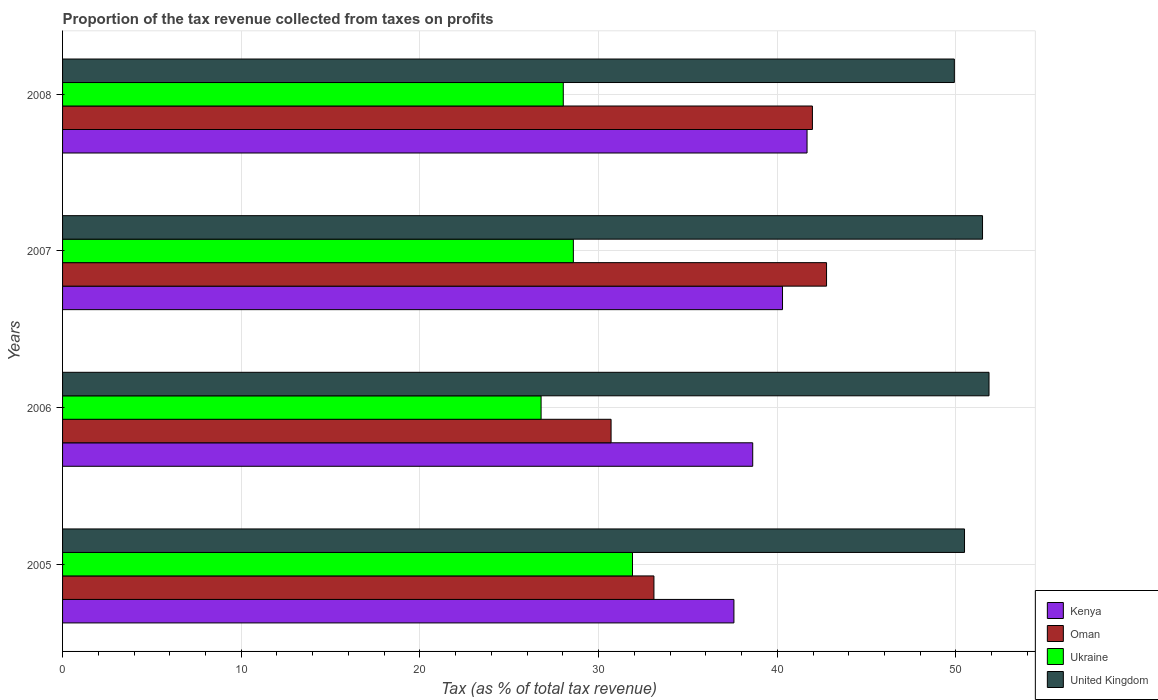How many groups of bars are there?
Your answer should be very brief. 4. Are the number of bars per tick equal to the number of legend labels?
Ensure brevity in your answer.  Yes. Are the number of bars on each tick of the Y-axis equal?
Offer a terse response. Yes. How many bars are there on the 1st tick from the bottom?
Your answer should be very brief. 4. What is the label of the 2nd group of bars from the top?
Offer a terse response. 2007. What is the proportion of the tax revenue collected in United Kingdom in 2005?
Offer a very short reply. 50.48. Across all years, what is the maximum proportion of the tax revenue collected in Ukraine?
Your answer should be very brief. 31.9. Across all years, what is the minimum proportion of the tax revenue collected in Ukraine?
Your response must be concise. 26.78. In which year was the proportion of the tax revenue collected in Ukraine maximum?
Keep it short and to the point. 2005. What is the total proportion of the tax revenue collected in Kenya in the graph?
Give a very brief answer. 158.15. What is the difference between the proportion of the tax revenue collected in Oman in 2005 and that in 2007?
Your response must be concise. -9.66. What is the difference between the proportion of the tax revenue collected in United Kingdom in 2005 and the proportion of the tax revenue collected in Oman in 2007?
Offer a terse response. 7.72. What is the average proportion of the tax revenue collected in Kenya per year?
Keep it short and to the point. 39.54. In the year 2005, what is the difference between the proportion of the tax revenue collected in Kenya and proportion of the tax revenue collected in Ukraine?
Offer a very short reply. 5.68. What is the ratio of the proportion of the tax revenue collected in Oman in 2006 to that in 2007?
Give a very brief answer. 0.72. Is the proportion of the tax revenue collected in Oman in 2005 less than that in 2007?
Offer a very short reply. Yes. What is the difference between the highest and the second highest proportion of the tax revenue collected in Ukraine?
Ensure brevity in your answer.  3.31. What is the difference between the highest and the lowest proportion of the tax revenue collected in Ukraine?
Give a very brief answer. 5.12. In how many years, is the proportion of the tax revenue collected in Oman greater than the average proportion of the tax revenue collected in Oman taken over all years?
Provide a succinct answer. 2. Is it the case that in every year, the sum of the proportion of the tax revenue collected in Ukraine and proportion of the tax revenue collected in Kenya is greater than the sum of proportion of the tax revenue collected in Oman and proportion of the tax revenue collected in United Kingdom?
Provide a short and direct response. Yes. What does the 2nd bar from the top in 2007 represents?
Provide a succinct answer. Ukraine. How many years are there in the graph?
Make the answer very short. 4. What is the difference between two consecutive major ticks on the X-axis?
Your answer should be very brief. 10. Does the graph contain any zero values?
Provide a succinct answer. No. Where does the legend appear in the graph?
Offer a terse response. Bottom right. How are the legend labels stacked?
Keep it short and to the point. Vertical. What is the title of the graph?
Keep it short and to the point. Proportion of the tax revenue collected from taxes on profits. What is the label or title of the X-axis?
Offer a terse response. Tax (as % of total tax revenue). What is the Tax (as % of total tax revenue) in Kenya in 2005?
Provide a short and direct response. 37.57. What is the Tax (as % of total tax revenue) of Oman in 2005?
Offer a very short reply. 33.1. What is the Tax (as % of total tax revenue) of Ukraine in 2005?
Make the answer very short. 31.9. What is the Tax (as % of total tax revenue) of United Kingdom in 2005?
Your answer should be very brief. 50.48. What is the Tax (as % of total tax revenue) of Kenya in 2006?
Give a very brief answer. 38.62. What is the Tax (as % of total tax revenue) of Oman in 2006?
Make the answer very short. 30.7. What is the Tax (as % of total tax revenue) of Ukraine in 2006?
Ensure brevity in your answer.  26.78. What is the Tax (as % of total tax revenue) in United Kingdom in 2006?
Make the answer very short. 51.85. What is the Tax (as % of total tax revenue) of Kenya in 2007?
Your answer should be compact. 40.29. What is the Tax (as % of total tax revenue) of Oman in 2007?
Offer a very short reply. 42.76. What is the Tax (as % of total tax revenue) in Ukraine in 2007?
Keep it short and to the point. 28.59. What is the Tax (as % of total tax revenue) of United Kingdom in 2007?
Give a very brief answer. 51.49. What is the Tax (as % of total tax revenue) in Kenya in 2008?
Your answer should be compact. 41.67. What is the Tax (as % of total tax revenue) in Oman in 2008?
Ensure brevity in your answer.  41.97. What is the Tax (as % of total tax revenue) in Ukraine in 2008?
Offer a terse response. 28.02. What is the Tax (as % of total tax revenue) in United Kingdom in 2008?
Give a very brief answer. 49.91. Across all years, what is the maximum Tax (as % of total tax revenue) of Kenya?
Provide a succinct answer. 41.67. Across all years, what is the maximum Tax (as % of total tax revenue) of Oman?
Offer a terse response. 42.76. Across all years, what is the maximum Tax (as % of total tax revenue) of Ukraine?
Make the answer very short. 31.9. Across all years, what is the maximum Tax (as % of total tax revenue) in United Kingdom?
Offer a terse response. 51.85. Across all years, what is the minimum Tax (as % of total tax revenue) of Kenya?
Your answer should be very brief. 37.57. Across all years, what is the minimum Tax (as % of total tax revenue) in Oman?
Provide a short and direct response. 30.7. Across all years, what is the minimum Tax (as % of total tax revenue) in Ukraine?
Make the answer very short. 26.78. Across all years, what is the minimum Tax (as % of total tax revenue) of United Kingdom?
Provide a short and direct response. 49.91. What is the total Tax (as % of total tax revenue) of Kenya in the graph?
Give a very brief answer. 158.15. What is the total Tax (as % of total tax revenue) of Oman in the graph?
Offer a very short reply. 148.51. What is the total Tax (as % of total tax revenue) of Ukraine in the graph?
Ensure brevity in your answer.  115.29. What is the total Tax (as % of total tax revenue) of United Kingdom in the graph?
Give a very brief answer. 203.72. What is the difference between the Tax (as % of total tax revenue) of Kenya in 2005 and that in 2006?
Provide a short and direct response. -1.05. What is the difference between the Tax (as % of total tax revenue) of Oman in 2005 and that in 2006?
Keep it short and to the point. 2.4. What is the difference between the Tax (as % of total tax revenue) of Ukraine in 2005 and that in 2006?
Ensure brevity in your answer.  5.12. What is the difference between the Tax (as % of total tax revenue) of United Kingdom in 2005 and that in 2006?
Your response must be concise. -1.37. What is the difference between the Tax (as % of total tax revenue) in Kenya in 2005 and that in 2007?
Ensure brevity in your answer.  -2.72. What is the difference between the Tax (as % of total tax revenue) in Oman in 2005 and that in 2007?
Your answer should be compact. -9.66. What is the difference between the Tax (as % of total tax revenue) of Ukraine in 2005 and that in 2007?
Make the answer very short. 3.31. What is the difference between the Tax (as % of total tax revenue) of United Kingdom in 2005 and that in 2007?
Your answer should be very brief. -1.01. What is the difference between the Tax (as % of total tax revenue) in Kenya in 2005 and that in 2008?
Your answer should be very brief. -4.09. What is the difference between the Tax (as % of total tax revenue) in Oman in 2005 and that in 2008?
Ensure brevity in your answer.  -8.87. What is the difference between the Tax (as % of total tax revenue) in Ukraine in 2005 and that in 2008?
Offer a terse response. 3.87. What is the difference between the Tax (as % of total tax revenue) of United Kingdom in 2005 and that in 2008?
Your answer should be compact. 0.57. What is the difference between the Tax (as % of total tax revenue) of Kenya in 2006 and that in 2007?
Provide a short and direct response. -1.67. What is the difference between the Tax (as % of total tax revenue) in Oman in 2006 and that in 2007?
Provide a short and direct response. -12.06. What is the difference between the Tax (as % of total tax revenue) of Ukraine in 2006 and that in 2007?
Provide a short and direct response. -1.81. What is the difference between the Tax (as % of total tax revenue) in United Kingdom in 2006 and that in 2007?
Your answer should be very brief. 0.36. What is the difference between the Tax (as % of total tax revenue) of Kenya in 2006 and that in 2008?
Provide a short and direct response. -3.04. What is the difference between the Tax (as % of total tax revenue) in Oman in 2006 and that in 2008?
Provide a succinct answer. -11.27. What is the difference between the Tax (as % of total tax revenue) in Ukraine in 2006 and that in 2008?
Your response must be concise. -1.24. What is the difference between the Tax (as % of total tax revenue) in United Kingdom in 2006 and that in 2008?
Make the answer very short. 1.94. What is the difference between the Tax (as % of total tax revenue) in Kenya in 2007 and that in 2008?
Ensure brevity in your answer.  -1.37. What is the difference between the Tax (as % of total tax revenue) of Oman in 2007 and that in 2008?
Provide a short and direct response. 0.79. What is the difference between the Tax (as % of total tax revenue) in Ukraine in 2007 and that in 2008?
Keep it short and to the point. 0.56. What is the difference between the Tax (as % of total tax revenue) of United Kingdom in 2007 and that in 2008?
Your response must be concise. 1.58. What is the difference between the Tax (as % of total tax revenue) of Kenya in 2005 and the Tax (as % of total tax revenue) of Oman in 2006?
Make the answer very short. 6.88. What is the difference between the Tax (as % of total tax revenue) in Kenya in 2005 and the Tax (as % of total tax revenue) in Ukraine in 2006?
Make the answer very short. 10.79. What is the difference between the Tax (as % of total tax revenue) in Kenya in 2005 and the Tax (as % of total tax revenue) in United Kingdom in 2006?
Give a very brief answer. -14.28. What is the difference between the Tax (as % of total tax revenue) in Oman in 2005 and the Tax (as % of total tax revenue) in Ukraine in 2006?
Give a very brief answer. 6.32. What is the difference between the Tax (as % of total tax revenue) of Oman in 2005 and the Tax (as % of total tax revenue) of United Kingdom in 2006?
Your response must be concise. -18.75. What is the difference between the Tax (as % of total tax revenue) of Ukraine in 2005 and the Tax (as % of total tax revenue) of United Kingdom in 2006?
Provide a succinct answer. -19.95. What is the difference between the Tax (as % of total tax revenue) of Kenya in 2005 and the Tax (as % of total tax revenue) of Oman in 2007?
Your response must be concise. -5.18. What is the difference between the Tax (as % of total tax revenue) of Kenya in 2005 and the Tax (as % of total tax revenue) of Ukraine in 2007?
Your response must be concise. 8.99. What is the difference between the Tax (as % of total tax revenue) of Kenya in 2005 and the Tax (as % of total tax revenue) of United Kingdom in 2007?
Offer a terse response. -13.91. What is the difference between the Tax (as % of total tax revenue) of Oman in 2005 and the Tax (as % of total tax revenue) of Ukraine in 2007?
Give a very brief answer. 4.51. What is the difference between the Tax (as % of total tax revenue) of Oman in 2005 and the Tax (as % of total tax revenue) of United Kingdom in 2007?
Offer a terse response. -18.39. What is the difference between the Tax (as % of total tax revenue) of Ukraine in 2005 and the Tax (as % of total tax revenue) of United Kingdom in 2007?
Provide a succinct answer. -19.59. What is the difference between the Tax (as % of total tax revenue) in Kenya in 2005 and the Tax (as % of total tax revenue) in Oman in 2008?
Your answer should be very brief. -4.39. What is the difference between the Tax (as % of total tax revenue) in Kenya in 2005 and the Tax (as % of total tax revenue) in Ukraine in 2008?
Provide a short and direct response. 9.55. What is the difference between the Tax (as % of total tax revenue) of Kenya in 2005 and the Tax (as % of total tax revenue) of United Kingdom in 2008?
Make the answer very short. -12.34. What is the difference between the Tax (as % of total tax revenue) in Oman in 2005 and the Tax (as % of total tax revenue) in Ukraine in 2008?
Provide a short and direct response. 5.07. What is the difference between the Tax (as % of total tax revenue) of Oman in 2005 and the Tax (as % of total tax revenue) of United Kingdom in 2008?
Your answer should be compact. -16.81. What is the difference between the Tax (as % of total tax revenue) in Ukraine in 2005 and the Tax (as % of total tax revenue) in United Kingdom in 2008?
Provide a short and direct response. -18.01. What is the difference between the Tax (as % of total tax revenue) of Kenya in 2006 and the Tax (as % of total tax revenue) of Oman in 2007?
Offer a very short reply. -4.13. What is the difference between the Tax (as % of total tax revenue) in Kenya in 2006 and the Tax (as % of total tax revenue) in Ukraine in 2007?
Make the answer very short. 10.04. What is the difference between the Tax (as % of total tax revenue) in Kenya in 2006 and the Tax (as % of total tax revenue) in United Kingdom in 2007?
Offer a very short reply. -12.86. What is the difference between the Tax (as % of total tax revenue) in Oman in 2006 and the Tax (as % of total tax revenue) in Ukraine in 2007?
Your answer should be compact. 2.11. What is the difference between the Tax (as % of total tax revenue) in Oman in 2006 and the Tax (as % of total tax revenue) in United Kingdom in 2007?
Provide a short and direct response. -20.79. What is the difference between the Tax (as % of total tax revenue) of Ukraine in 2006 and the Tax (as % of total tax revenue) of United Kingdom in 2007?
Offer a terse response. -24.71. What is the difference between the Tax (as % of total tax revenue) in Kenya in 2006 and the Tax (as % of total tax revenue) in Oman in 2008?
Ensure brevity in your answer.  -3.34. What is the difference between the Tax (as % of total tax revenue) in Kenya in 2006 and the Tax (as % of total tax revenue) in Ukraine in 2008?
Offer a very short reply. 10.6. What is the difference between the Tax (as % of total tax revenue) in Kenya in 2006 and the Tax (as % of total tax revenue) in United Kingdom in 2008?
Provide a succinct answer. -11.28. What is the difference between the Tax (as % of total tax revenue) of Oman in 2006 and the Tax (as % of total tax revenue) of Ukraine in 2008?
Keep it short and to the point. 2.67. What is the difference between the Tax (as % of total tax revenue) of Oman in 2006 and the Tax (as % of total tax revenue) of United Kingdom in 2008?
Offer a very short reply. -19.21. What is the difference between the Tax (as % of total tax revenue) of Ukraine in 2006 and the Tax (as % of total tax revenue) of United Kingdom in 2008?
Keep it short and to the point. -23.13. What is the difference between the Tax (as % of total tax revenue) of Kenya in 2007 and the Tax (as % of total tax revenue) of Oman in 2008?
Provide a succinct answer. -1.67. What is the difference between the Tax (as % of total tax revenue) in Kenya in 2007 and the Tax (as % of total tax revenue) in Ukraine in 2008?
Provide a short and direct response. 12.27. What is the difference between the Tax (as % of total tax revenue) of Kenya in 2007 and the Tax (as % of total tax revenue) of United Kingdom in 2008?
Your response must be concise. -9.62. What is the difference between the Tax (as % of total tax revenue) in Oman in 2007 and the Tax (as % of total tax revenue) in Ukraine in 2008?
Offer a terse response. 14.73. What is the difference between the Tax (as % of total tax revenue) of Oman in 2007 and the Tax (as % of total tax revenue) of United Kingdom in 2008?
Keep it short and to the point. -7.15. What is the difference between the Tax (as % of total tax revenue) in Ukraine in 2007 and the Tax (as % of total tax revenue) in United Kingdom in 2008?
Your answer should be compact. -21.32. What is the average Tax (as % of total tax revenue) in Kenya per year?
Offer a very short reply. 39.54. What is the average Tax (as % of total tax revenue) of Oman per year?
Make the answer very short. 37.13. What is the average Tax (as % of total tax revenue) in Ukraine per year?
Offer a very short reply. 28.82. What is the average Tax (as % of total tax revenue) in United Kingdom per year?
Offer a very short reply. 50.93. In the year 2005, what is the difference between the Tax (as % of total tax revenue) in Kenya and Tax (as % of total tax revenue) in Oman?
Give a very brief answer. 4.48. In the year 2005, what is the difference between the Tax (as % of total tax revenue) of Kenya and Tax (as % of total tax revenue) of Ukraine?
Give a very brief answer. 5.68. In the year 2005, what is the difference between the Tax (as % of total tax revenue) of Kenya and Tax (as % of total tax revenue) of United Kingdom?
Ensure brevity in your answer.  -12.91. In the year 2005, what is the difference between the Tax (as % of total tax revenue) of Oman and Tax (as % of total tax revenue) of Ukraine?
Your response must be concise. 1.2. In the year 2005, what is the difference between the Tax (as % of total tax revenue) of Oman and Tax (as % of total tax revenue) of United Kingdom?
Your answer should be compact. -17.38. In the year 2005, what is the difference between the Tax (as % of total tax revenue) in Ukraine and Tax (as % of total tax revenue) in United Kingdom?
Offer a terse response. -18.58. In the year 2006, what is the difference between the Tax (as % of total tax revenue) in Kenya and Tax (as % of total tax revenue) in Oman?
Provide a short and direct response. 7.93. In the year 2006, what is the difference between the Tax (as % of total tax revenue) in Kenya and Tax (as % of total tax revenue) in Ukraine?
Offer a terse response. 11.84. In the year 2006, what is the difference between the Tax (as % of total tax revenue) in Kenya and Tax (as % of total tax revenue) in United Kingdom?
Make the answer very short. -13.22. In the year 2006, what is the difference between the Tax (as % of total tax revenue) in Oman and Tax (as % of total tax revenue) in Ukraine?
Ensure brevity in your answer.  3.92. In the year 2006, what is the difference between the Tax (as % of total tax revenue) of Oman and Tax (as % of total tax revenue) of United Kingdom?
Your response must be concise. -21.15. In the year 2006, what is the difference between the Tax (as % of total tax revenue) of Ukraine and Tax (as % of total tax revenue) of United Kingdom?
Offer a terse response. -25.07. In the year 2007, what is the difference between the Tax (as % of total tax revenue) in Kenya and Tax (as % of total tax revenue) in Oman?
Your answer should be very brief. -2.46. In the year 2007, what is the difference between the Tax (as % of total tax revenue) of Kenya and Tax (as % of total tax revenue) of Ukraine?
Make the answer very short. 11.71. In the year 2007, what is the difference between the Tax (as % of total tax revenue) in Kenya and Tax (as % of total tax revenue) in United Kingdom?
Make the answer very short. -11.19. In the year 2007, what is the difference between the Tax (as % of total tax revenue) of Oman and Tax (as % of total tax revenue) of Ukraine?
Offer a terse response. 14.17. In the year 2007, what is the difference between the Tax (as % of total tax revenue) in Oman and Tax (as % of total tax revenue) in United Kingdom?
Keep it short and to the point. -8.73. In the year 2007, what is the difference between the Tax (as % of total tax revenue) in Ukraine and Tax (as % of total tax revenue) in United Kingdom?
Your response must be concise. -22.9. In the year 2008, what is the difference between the Tax (as % of total tax revenue) in Kenya and Tax (as % of total tax revenue) in Oman?
Ensure brevity in your answer.  -0.3. In the year 2008, what is the difference between the Tax (as % of total tax revenue) of Kenya and Tax (as % of total tax revenue) of Ukraine?
Provide a succinct answer. 13.64. In the year 2008, what is the difference between the Tax (as % of total tax revenue) of Kenya and Tax (as % of total tax revenue) of United Kingdom?
Offer a terse response. -8.24. In the year 2008, what is the difference between the Tax (as % of total tax revenue) in Oman and Tax (as % of total tax revenue) in Ukraine?
Provide a succinct answer. 13.94. In the year 2008, what is the difference between the Tax (as % of total tax revenue) in Oman and Tax (as % of total tax revenue) in United Kingdom?
Keep it short and to the point. -7.94. In the year 2008, what is the difference between the Tax (as % of total tax revenue) in Ukraine and Tax (as % of total tax revenue) in United Kingdom?
Give a very brief answer. -21.89. What is the ratio of the Tax (as % of total tax revenue) in Kenya in 2005 to that in 2006?
Your answer should be very brief. 0.97. What is the ratio of the Tax (as % of total tax revenue) in Oman in 2005 to that in 2006?
Your answer should be compact. 1.08. What is the ratio of the Tax (as % of total tax revenue) in Ukraine in 2005 to that in 2006?
Make the answer very short. 1.19. What is the ratio of the Tax (as % of total tax revenue) in United Kingdom in 2005 to that in 2006?
Keep it short and to the point. 0.97. What is the ratio of the Tax (as % of total tax revenue) of Kenya in 2005 to that in 2007?
Provide a short and direct response. 0.93. What is the ratio of the Tax (as % of total tax revenue) of Oman in 2005 to that in 2007?
Give a very brief answer. 0.77. What is the ratio of the Tax (as % of total tax revenue) in Ukraine in 2005 to that in 2007?
Provide a succinct answer. 1.12. What is the ratio of the Tax (as % of total tax revenue) of United Kingdom in 2005 to that in 2007?
Your answer should be very brief. 0.98. What is the ratio of the Tax (as % of total tax revenue) of Kenya in 2005 to that in 2008?
Keep it short and to the point. 0.9. What is the ratio of the Tax (as % of total tax revenue) in Oman in 2005 to that in 2008?
Offer a terse response. 0.79. What is the ratio of the Tax (as % of total tax revenue) of Ukraine in 2005 to that in 2008?
Offer a terse response. 1.14. What is the ratio of the Tax (as % of total tax revenue) in United Kingdom in 2005 to that in 2008?
Provide a succinct answer. 1.01. What is the ratio of the Tax (as % of total tax revenue) in Kenya in 2006 to that in 2007?
Your answer should be very brief. 0.96. What is the ratio of the Tax (as % of total tax revenue) in Oman in 2006 to that in 2007?
Your response must be concise. 0.72. What is the ratio of the Tax (as % of total tax revenue) of Ukraine in 2006 to that in 2007?
Your answer should be compact. 0.94. What is the ratio of the Tax (as % of total tax revenue) of Kenya in 2006 to that in 2008?
Offer a terse response. 0.93. What is the ratio of the Tax (as % of total tax revenue) in Oman in 2006 to that in 2008?
Offer a terse response. 0.73. What is the ratio of the Tax (as % of total tax revenue) in Ukraine in 2006 to that in 2008?
Ensure brevity in your answer.  0.96. What is the ratio of the Tax (as % of total tax revenue) of United Kingdom in 2006 to that in 2008?
Provide a short and direct response. 1.04. What is the ratio of the Tax (as % of total tax revenue) in Kenya in 2007 to that in 2008?
Ensure brevity in your answer.  0.97. What is the ratio of the Tax (as % of total tax revenue) of Oman in 2007 to that in 2008?
Your response must be concise. 1.02. What is the ratio of the Tax (as % of total tax revenue) of Ukraine in 2007 to that in 2008?
Ensure brevity in your answer.  1.02. What is the ratio of the Tax (as % of total tax revenue) of United Kingdom in 2007 to that in 2008?
Your response must be concise. 1.03. What is the difference between the highest and the second highest Tax (as % of total tax revenue) of Kenya?
Provide a short and direct response. 1.37. What is the difference between the highest and the second highest Tax (as % of total tax revenue) of Oman?
Offer a very short reply. 0.79. What is the difference between the highest and the second highest Tax (as % of total tax revenue) in Ukraine?
Your response must be concise. 3.31. What is the difference between the highest and the second highest Tax (as % of total tax revenue) in United Kingdom?
Provide a succinct answer. 0.36. What is the difference between the highest and the lowest Tax (as % of total tax revenue) in Kenya?
Offer a very short reply. 4.09. What is the difference between the highest and the lowest Tax (as % of total tax revenue) in Oman?
Provide a short and direct response. 12.06. What is the difference between the highest and the lowest Tax (as % of total tax revenue) in Ukraine?
Your answer should be compact. 5.12. What is the difference between the highest and the lowest Tax (as % of total tax revenue) of United Kingdom?
Ensure brevity in your answer.  1.94. 